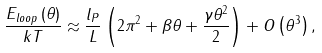<formula> <loc_0><loc_0><loc_500><loc_500>\frac { E _ { l o o p } \left ( \theta \right ) } { k T } \approx \frac { l _ { P } } { L } \left ( 2 \pi ^ { 2 } + \beta \theta + \frac { \gamma \theta ^ { 2 } } { 2 } \right ) + O \left ( \theta ^ { 3 } \right ) ,</formula> 